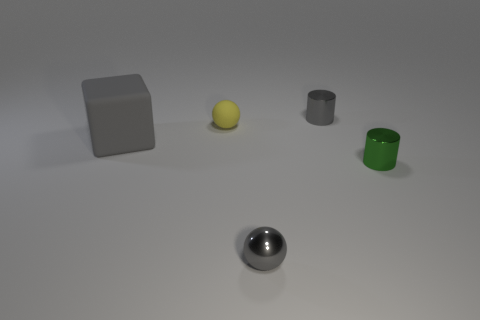There is a sphere in front of the gray object left of the small object that is in front of the small green object; how big is it? The sphere in question appears to be relatively small in size, comparable to the small objects surrounding it. It is not the smallest object in the image but is also not large, suggesting it could be described as medium-sized within the context of the image. 